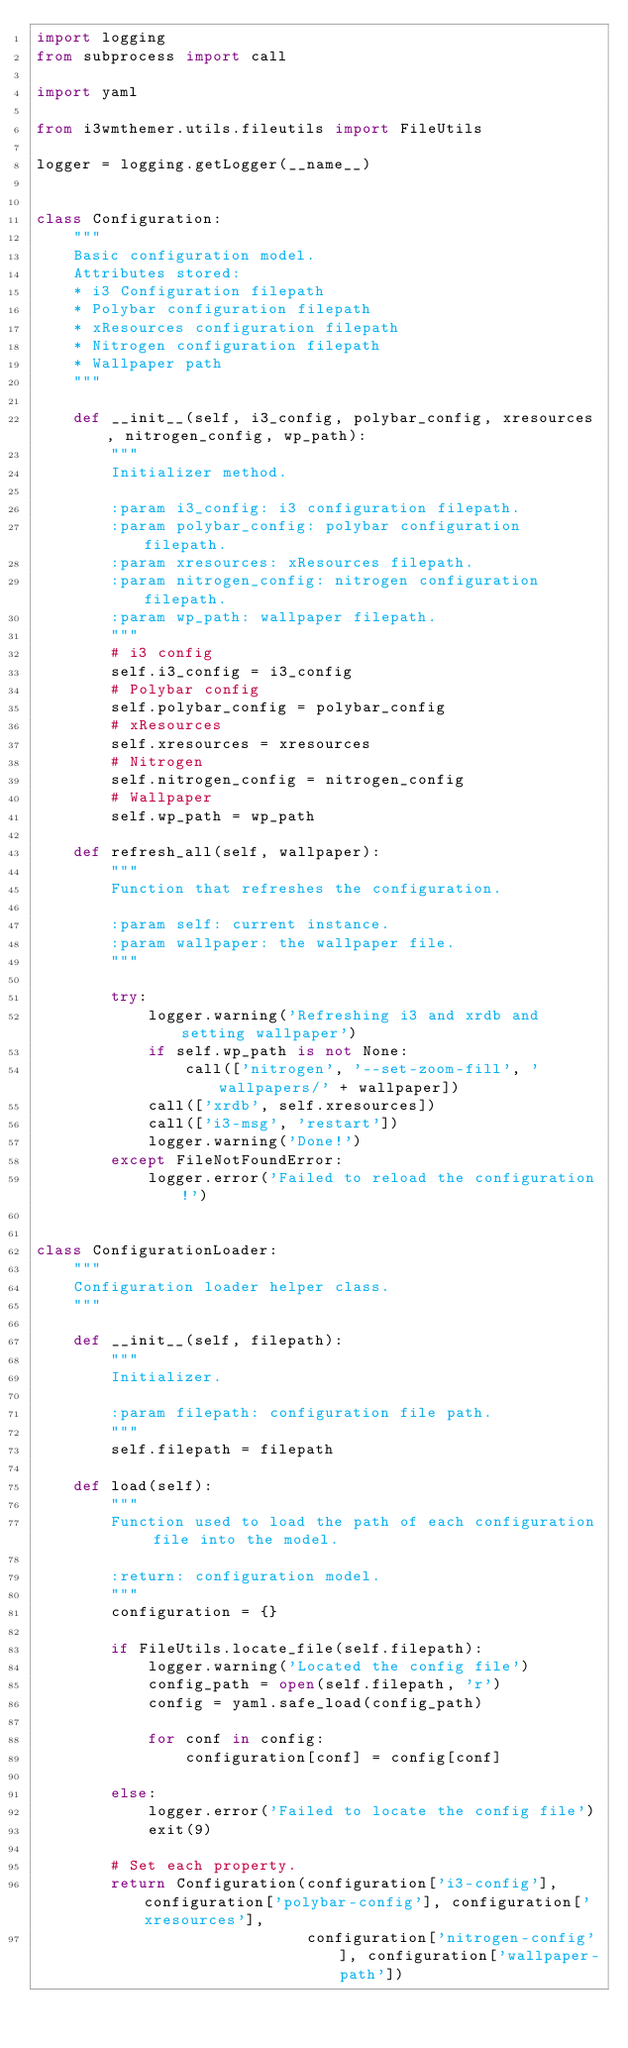Convert code to text. <code><loc_0><loc_0><loc_500><loc_500><_Python_>import logging
from subprocess import call

import yaml

from i3wmthemer.utils.fileutils import FileUtils

logger = logging.getLogger(__name__)


class Configuration:
    """
    Basic configuration model.
    Attributes stored:
    * i3 Configuration filepath
    * Polybar configuration filepath
    * xResources configuration filepath
    * Nitrogen configuration filepath
    * Wallpaper path
    """

    def __init__(self, i3_config, polybar_config, xresources, nitrogen_config, wp_path):
        """
        Initializer method.

        :param i3_config: i3 configuration filepath.
        :param polybar_config: polybar configuration filepath.
        :param xresources: xResources filepath.
        :param nitrogen_config: nitrogen configuration filepath.
        :param wp_path: wallpaper filepath.
        """
        # i3 config
        self.i3_config = i3_config
        # Polybar config
        self.polybar_config = polybar_config
        # xResources
        self.xresources = xresources
        # Nitrogen
        self.nitrogen_config = nitrogen_config
        # Wallpaper
        self.wp_path = wp_path

    def refresh_all(self, wallpaper):
        """
        Function that refreshes the configuration.

        :param self: current instance.
        :param wallpaper: the wallpaper file.
        """

        try:
            logger.warning('Refreshing i3 and xrdb and setting wallpaper')
            if self.wp_path is not None:
                call(['nitrogen', '--set-zoom-fill', 'wallpapers/' + wallpaper])
            call(['xrdb', self.xresources])
            call(['i3-msg', 'restart'])
            logger.warning('Done!')
        except FileNotFoundError:
            logger.error('Failed to reload the configuration!')


class ConfigurationLoader:
    """
    Configuration loader helper class.
    """

    def __init__(self, filepath):
        """
        Initializer.

        :param filepath: configuration file path.
        """
        self.filepath = filepath

    def load(self):
        """
        Function used to load the path of each configuration file into the model.

        :return: configuration model.
        """
        configuration = {}

        if FileUtils.locate_file(self.filepath):
            logger.warning('Located the config file')
            config_path = open(self.filepath, 'r')
            config = yaml.safe_load(config_path)
            
            for conf in config:
                configuration[conf] = config[conf]

        else:
            logger.error('Failed to locate the config file')
            exit(9)

        # Set each property.
        return Configuration(configuration['i3-config'], configuration['polybar-config'], configuration['xresources'],
                             configuration['nitrogen-config'], configuration['wallpaper-path'])
</code> 